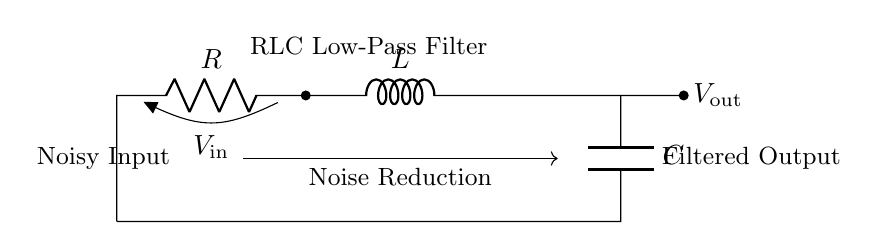What components are present in this circuit? The circuit contains a resistor (R), an inductor (L), and a capacitor (C), clearly labeled in the circuit diagram.
Answer: Resistor, Inductor, Capacitor What is the function of this circuit? The circuit is designed as a low-pass filter, allowing lower frequency signals to pass while attenuating higher frequency noise, which is indicated by the filter label.
Answer: Low-Pass Filter What is the input voltage denoted as? The input voltage in this circuit is labeled as V_insertéin, indicating the voltage applied to the input of the filter.
Answer: V_in Which component is connected to the output of this filter? The output of the circuit is connected to the capacitor (C), which suggests that this component plays a critical role in determining the filtered signal output.
Answer: Capacitor How does this circuit achieve noise reduction? The RLC filter allows low-frequency signals to pass while attenuating high-frequency noise, which is achieved through the combination of resistor, inductor, and capacitor in series.
Answer: Combination of R, L, and C What type of filter is this RLC configuration classified as? This RLC configuration is classified as a low-pass filter, as indicated by the labeling on the diagram and by its function to mitigate high-frequency noise in the signal.
Answer: Low-Pass Filter What is the role of the resistor in this circuit? The resistor in this circuit provides damping, which helps to control the amplitude of the output signal and prevents excessive ringing, thus enhancing stability in the filtering process.
Answer: Damping 